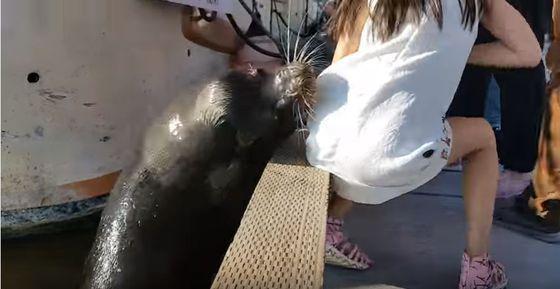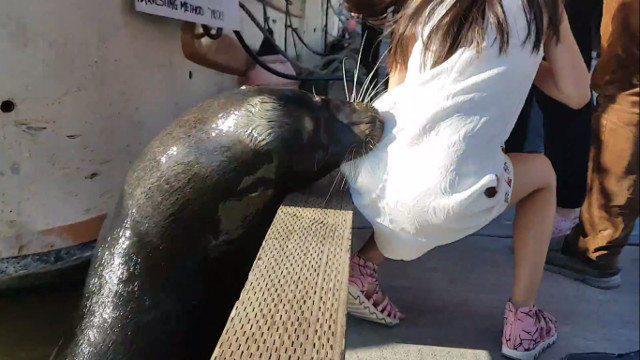The first image is the image on the left, the second image is the image on the right. Assess this claim about the two images: "In at least one of the images the girl's shoes are not visible.". Correct or not? Answer yes or no. No. 